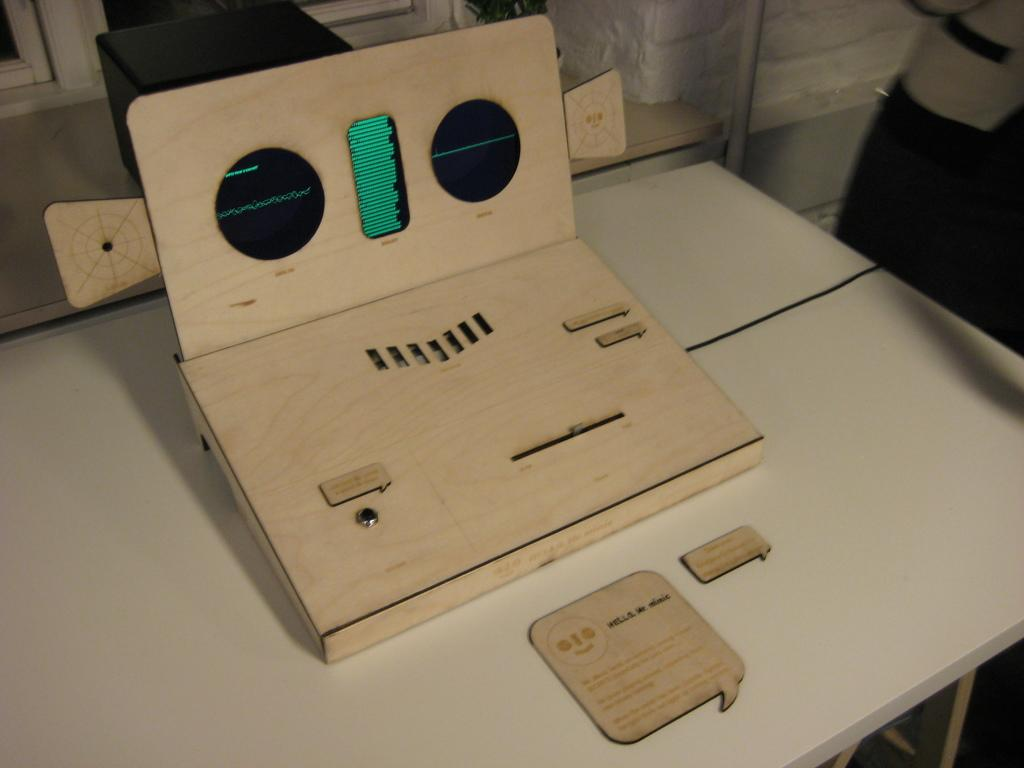What type of furniture is present in the image? There is a table in the image. What is placed on the table? There is a wooden object on the table. What can be seen through the window in the image? The image shows a window, but it does not provide a clear view of what is outside. Can you see the donkey's breath in the image? There is no donkey present in the image, so it is not possible to see its breath. 